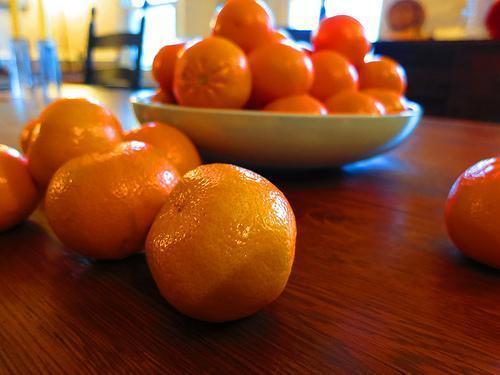How many different types of fruit are pictured?
Give a very brief answer. 1. 